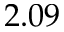<formula> <loc_0><loc_0><loc_500><loc_500>2 . 0 9</formula> 